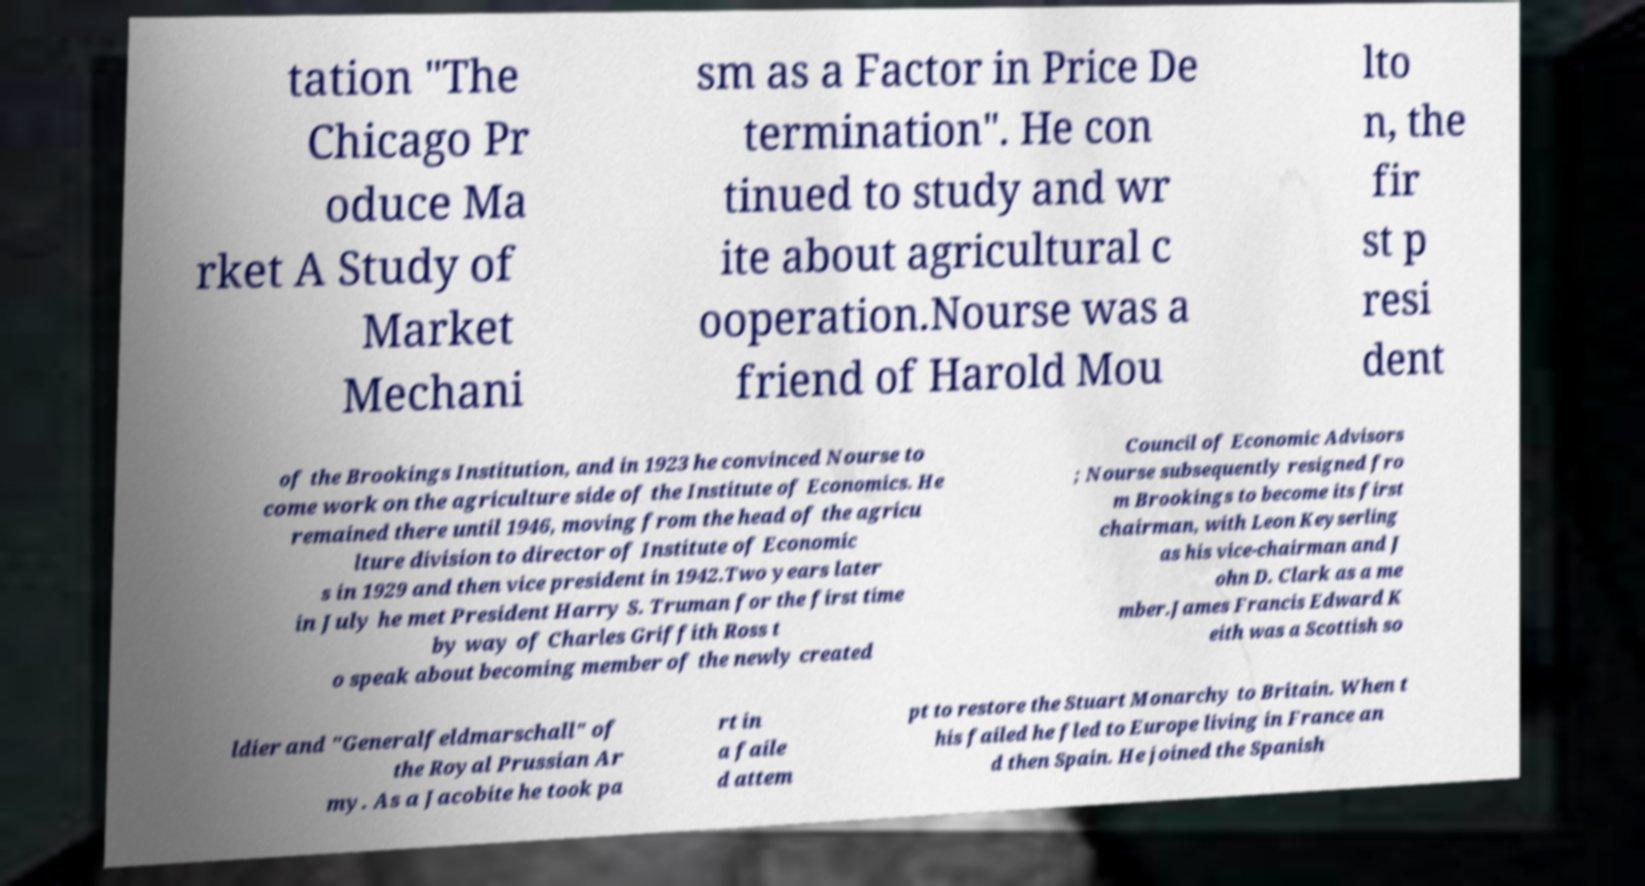For documentation purposes, I need the text within this image transcribed. Could you provide that? tation "The Chicago Pr oduce Ma rket A Study of Market Mechani sm as a Factor in Price De termination". He con tinued to study and wr ite about agricultural c ooperation.Nourse was a friend of Harold Mou lto n, the fir st p resi dent of the Brookings Institution, and in 1923 he convinced Nourse to come work on the agriculture side of the Institute of Economics. He remained there until 1946, moving from the head of the agricu lture division to director of Institute of Economic s in 1929 and then vice president in 1942.Two years later in July he met President Harry S. Truman for the first time by way of Charles Griffith Ross t o speak about becoming member of the newly created Council of Economic Advisors ; Nourse subsequently resigned fro m Brookings to become its first chairman, with Leon Keyserling as his vice-chairman and J ohn D. Clark as a me mber.James Francis Edward K eith was a Scottish so ldier and "Generalfeldmarschall" of the Royal Prussian Ar my. As a Jacobite he took pa rt in a faile d attem pt to restore the Stuart Monarchy to Britain. When t his failed he fled to Europe living in France an d then Spain. He joined the Spanish 